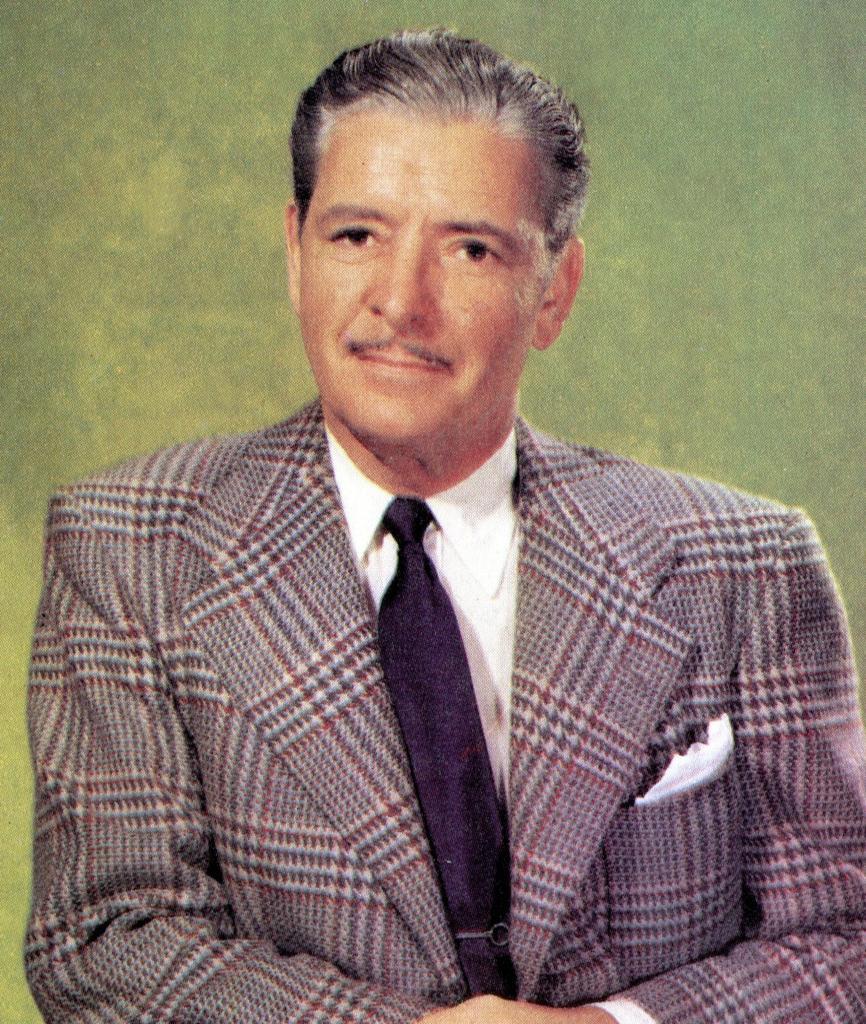How would you summarize this image in a sentence or two? In this picture I can see a person. 